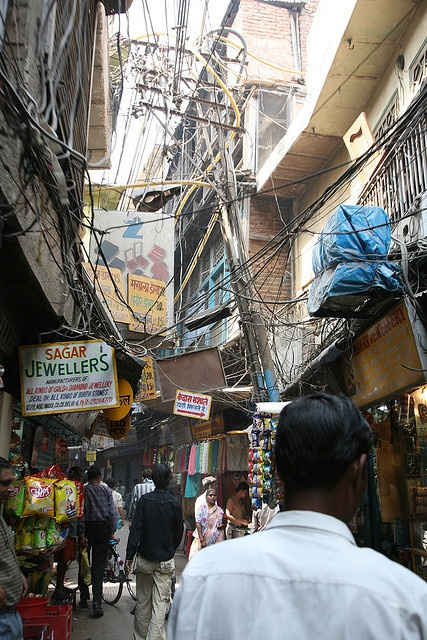Describe the objects in this image and their specific colors. I can see people in gray, lightgray, black, and darkgray tones, people in gray, black, and darkgray tones, people in gray, black, and darkgray tones, people in gray, black, and maroon tones, and people in gray, lightgray, darkgray, brown, and lightpink tones in this image. 